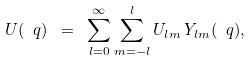Convert formula to latex. <formula><loc_0><loc_0><loc_500><loc_500>U ( \ q ) \ = \ \sum _ { l = 0 } ^ { \infty } \sum _ { m = - l } ^ { l } U _ { l m } \, Y _ { l m } ( \ q ) ,</formula> 